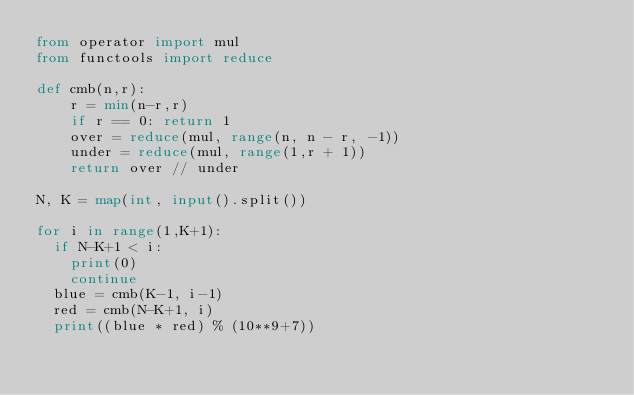Convert code to text. <code><loc_0><loc_0><loc_500><loc_500><_Python_>from operator import mul
from functools import reduce

def cmb(n,r):
    r = min(n-r,r)
    if r == 0: return 1
    over = reduce(mul, range(n, n - r, -1))
    under = reduce(mul, range(1,r + 1))
    return over // under
 
N, K = map(int, input().split())

for i in range(1,K+1):
  if N-K+1 < i:
    print(0)
    continue
  blue = cmb(K-1, i-1)
  red = cmb(N-K+1, i)
  print((blue * red) % (10**9+7))
</code> 